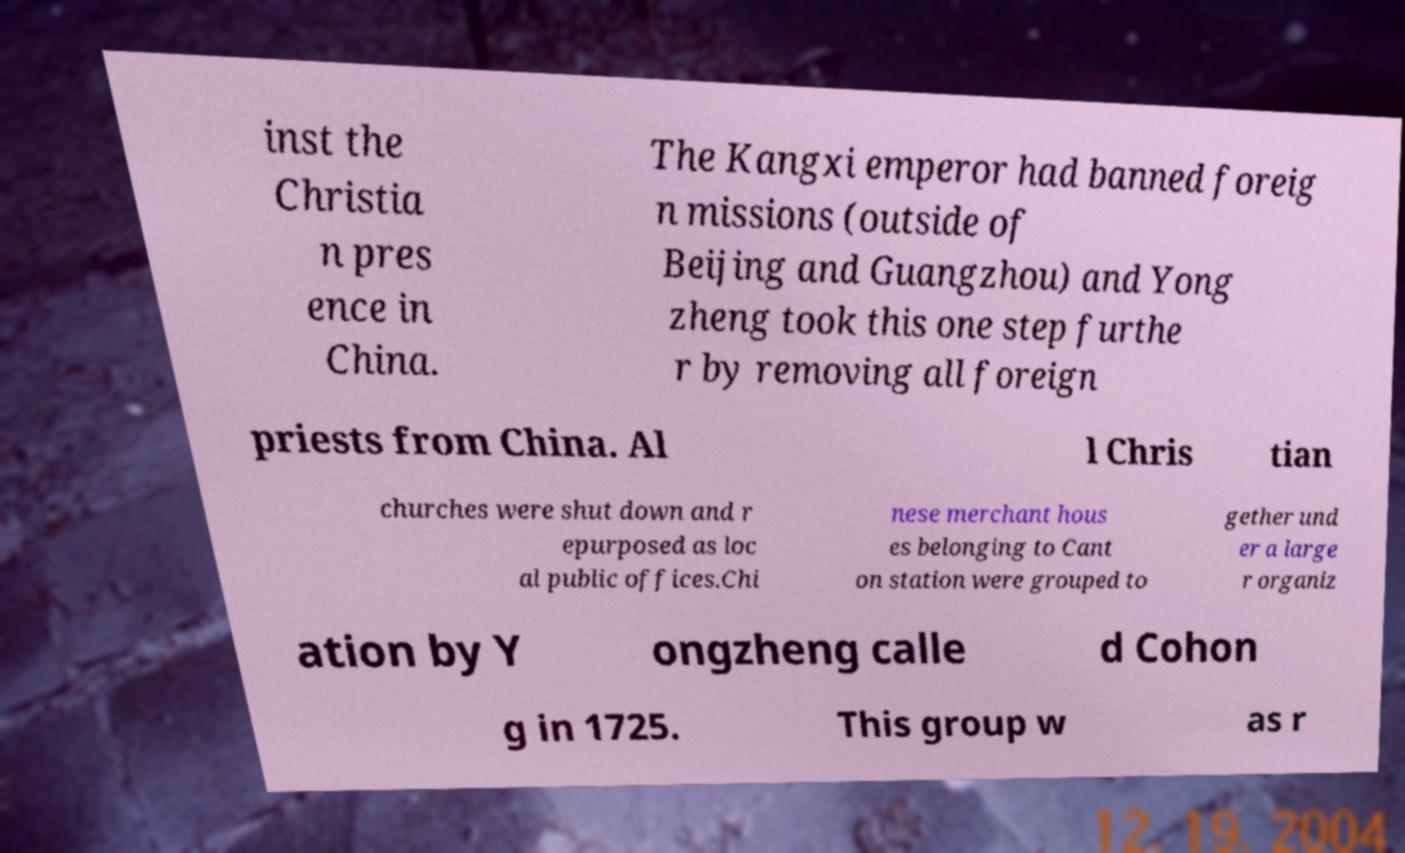Could you assist in decoding the text presented in this image and type it out clearly? inst the Christia n pres ence in China. The Kangxi emperor had banned foreig n missions (outside of Beijing and Guangzhou) and Yong zheng took this one step furthe r by removing all foreign priests from China. Al l Chris tian churches were shut down and r epurposed as loc al public offices.Chi nese merchant hous es belonging to Cant on station were grouped to gether und er a large r organiz ation by Y ongzheng calle d Cohon g in 1725. This group w as r 